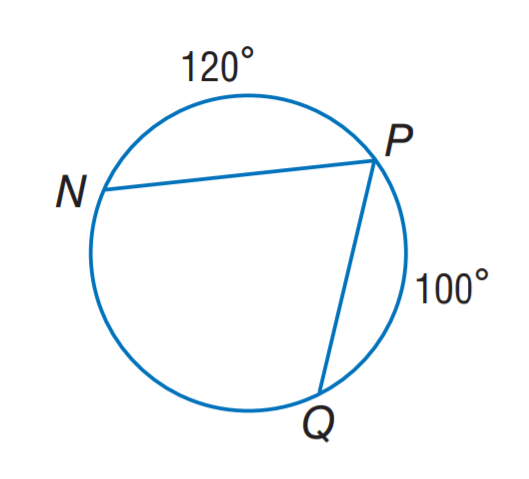Answer the mathemtical geometry problem and directly provide the correct option letter.
Question: Find m \angle P.
Choices: A: 60 B: 70 C: 100 D: 120 B 